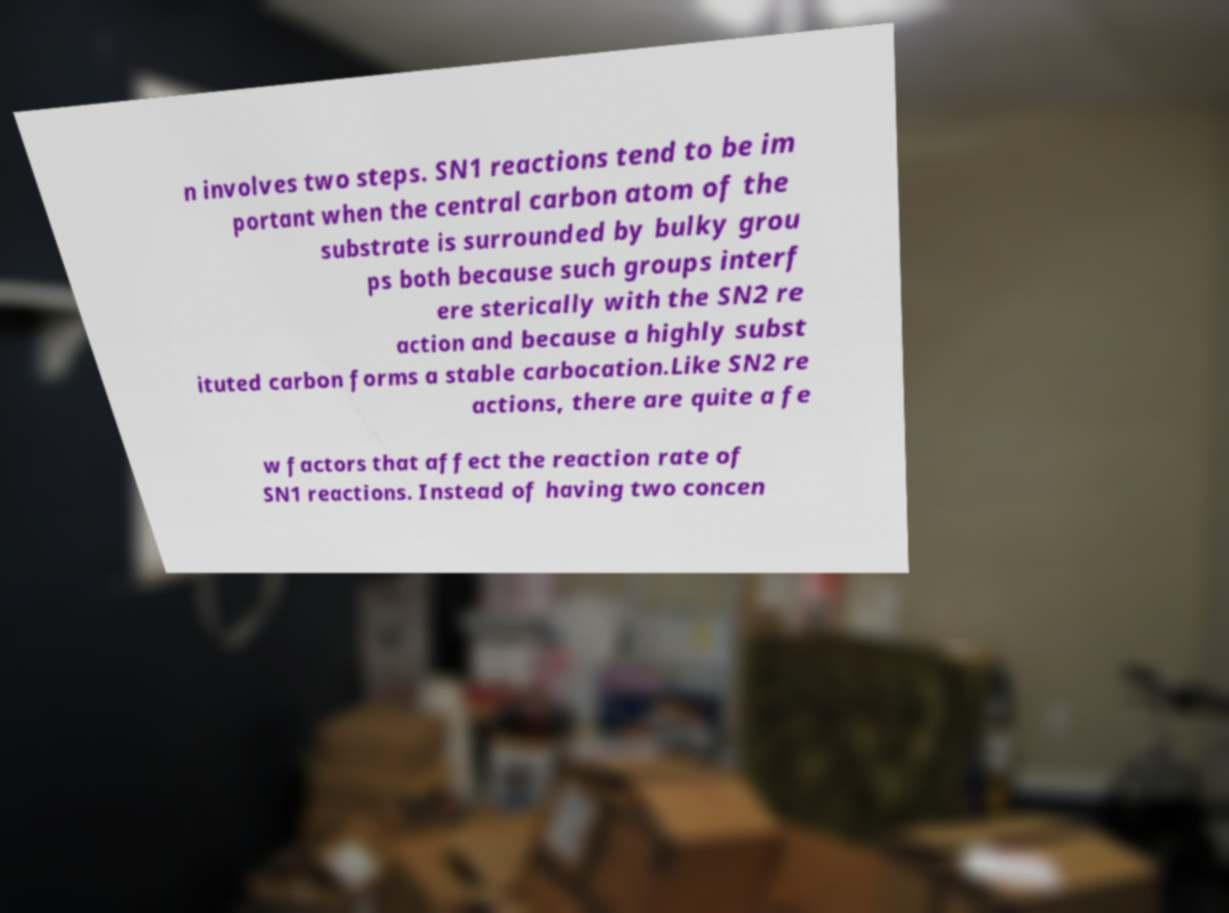Can you accurately transcribe the text from the provided image for me? n involves two steps. SN1 reactions tend to be im portant when the central carbon atom of the substrate is surrounded by bulky grou ps both because such groups interf ere sterically with the SN2 re action and because a highly subst ituted carbon forms a stable carbocation.Like SN2 re actions, there are quite a fe w factors that affect the reaction rate of SN1 reactions. Instead of having two concen 